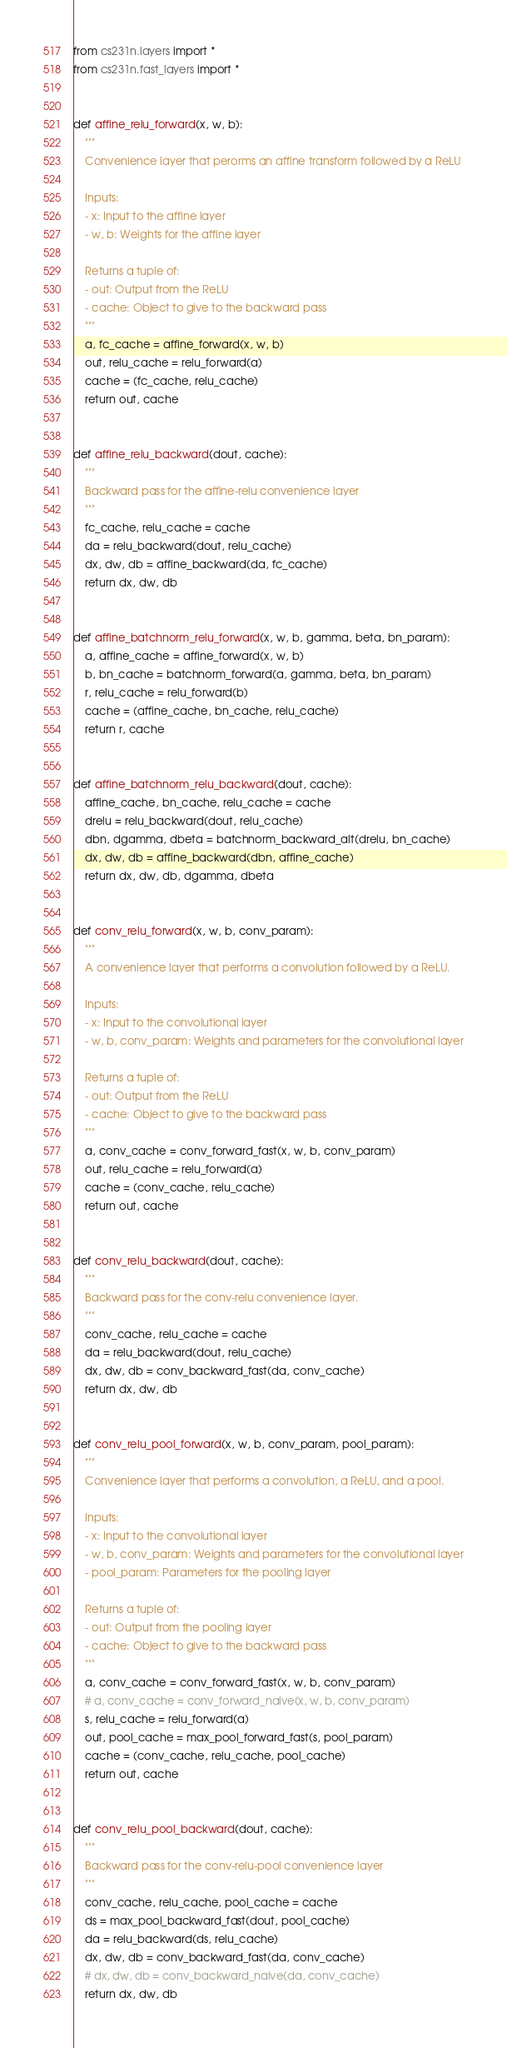<code> <loc_0><loc_0><loc_500><loc_500><_Python_>from cs231n.layers import *
from cs231n.fast_layers import *


def affine_relu_forward(x, w, b):
    """
    Convenience layer that perorms an affine transform followed by a ReLU

    Inputs:
    - x: Input to the affine layer
    - w, b: Weights for the affine layer

    Returns a tuple of:
    - out: Output from the ReLU
    - cache: Object to give to the backward pass
    """
    a, fc_cache = affine_forward(x, w, b)
    out, relu_cache = relu_forward(a)
    cache = (fc_cache, relu_cache)
    return out, cache


def affine_relu_backward(dout, cache):
    """
    Backward pass for the affine-relu convenience layer
    """
    fc_cache, relu_cache = cache
    da = relu_backward(dout, relu_cache)
    dx, dw, db = affine_backward(da, fc_cache)
    return dx, dw, db


def affine_batchnorm_relu_forward(x, w, b, gamma, beta, bn_param):
    a, affine_cache = affine_forward(x, w, b)
    b, bn_cache = batchnorm_forward(a, gamma, beta, bn_param)
    r, relu_cache = relu_forward(b)
    cache = (affine_cache, bn_cache, relu_cache)
    return r, cache


def affine_batchnorm_relu_backward(dout, cache):
    affine_cache, bn_cache, relu_cache = cache
    drelu = relu_backward(dout, relu_cache)
    dbn, dgamma, dbeta = batchnorm_backward_alt(drelu, bn_cache)
    dx, dw, db = affine_backward(dbn, affine_cache)
    return dx, dw, db, dgamma, dbeta


def conv_relu_forward(x, w, b, conv_param):
    """
    A convenience layer that performs a convolution followed by a ReLU.

    Inputs:
    - x: Input to the convolutional layer
    - w, b, conv_param: Weights and parameters for the convolutional layer

    Returns a tuple of:
    - out: Output from the ReLU
    - cache: Object to give to the backward pass
    """
    a, conv_cache = conv_forward_fast(x, w, b, conv_param)
    out, relu_cache = relu_forward(a)
    cache = (conv_cache, relu_cache)
    return out, cache


def conv_relu_backward(dout, cache):
    """
    Backward pass for the conv-relu convenience layer.
    """
    conv_cache, relu_cache = cache
    da = relu_backward(dout, relu_cache)
    dx, dw, db = conv_backward_fast(da, conv_cache)
    return dx, dw, db


def conv_relu_pool_forward(x, w, b, conv_param, pool_param):
    """
    Convenience layer that performs a convolution, a ReLU, and a pool.

    Inputs:
    - x: Input to the convolutional layer
    - w, b, conv_param: Weights and parameters for the convolutional layer
    - pool_param: Parameters for the pooling layer

    Returns a tuple of:
    - out: Output from the pooling layer
    - cache: Object to give to the backward pass
    """
    a, conv_cache = conv_forward_fast(x, w, b, conv_param)
    # a, conv_cache = conv_forward_naive(x, w, b, conv_param)
    s, relu_cache = relu_forward(a)
    out, pool_cache = max_pool_forward_fast(s, pool_param)
    cache = (conv_cache, relu_cache, pool_cache)
    return out, cache


def conv_relu_pool_backward(dout, cache):
    """
    Backward pass for the conv-relu-pool convenience layer
    """
    conv_cache, relu_cache, pool_cache = cache
    ds = max_pool_backward_fast(dout, pool_cache)
    da = relu_backward(ds, relu_cache)
    dx, dw, db = conv_backward_fast(da, conv_cache)
    # dx, dw, db = conv_backward_naive(da, conv_cache)
    return dx, dw, db
</code> 